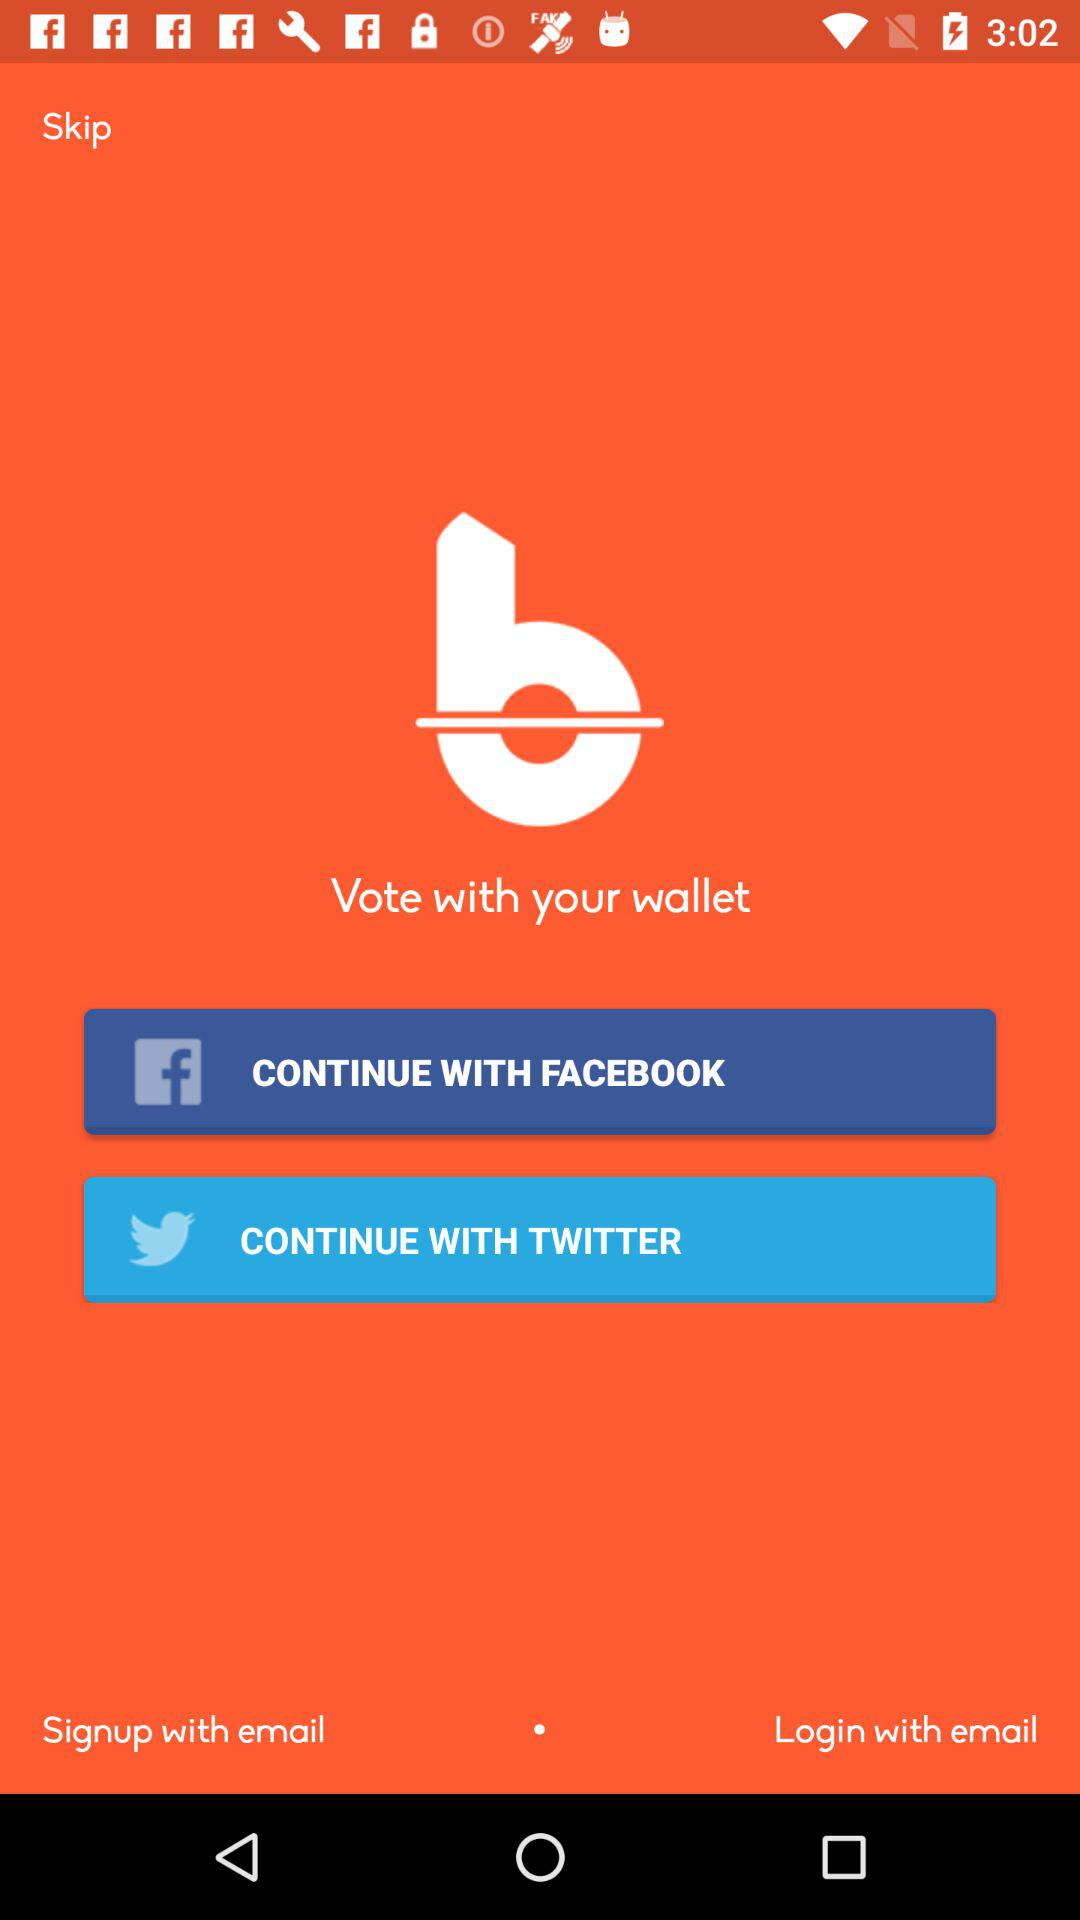Which applications can be used to continue? The applications that can be used to continue are "FACEBOOK" and "TWITTER". 